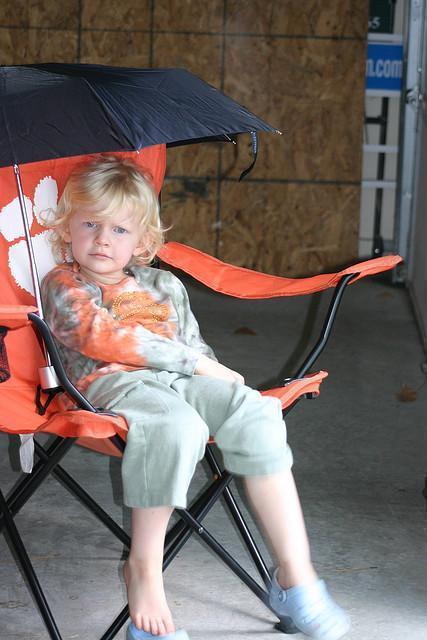What type of footwear is the boy wearing?
Answer the question by selecting the correct answer among the 4 following choices.
Options: Sneakers, sandals, converse, crocs. Crocs. 